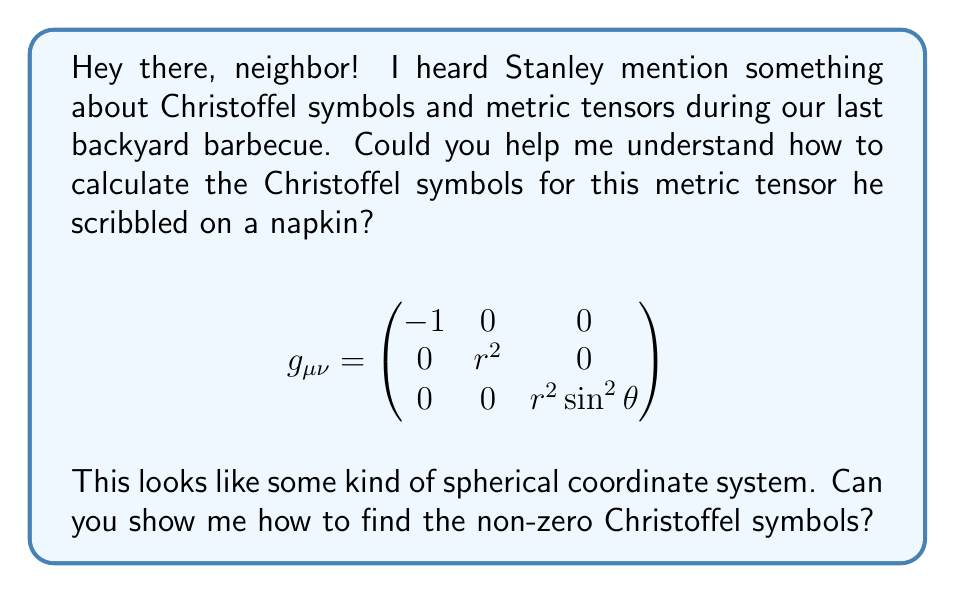What is the answer to this math problem? Sure, I'd be happy to help you understand this! Let's calculate the Christoffel symbols step-by-step:

1) The Christoffel symbols are given by the formula:

   $$\Gamma^\lambda_{\mu\nu} = \frac{1}{2}g^{\lambda\sigma}(\partial_\mu g_{\nu\sigma} + \partial_\nu g_{\mu\sigma} - \partial_\sigma g_{\mu\nu})$$

2) First, we need to find the inverse metric $g^{\mu\nu}$:

   $$g^{\mu\nu} = \begin{pmatrix}
   -1 & 0 & 0 \\
   0 & \frac{1}{r^2} & 0 \\
   0 & 0 & \frac{1}{r^2 \sin^2\theta}
   \end{pmatrix}$$

3) Now, let's calculate the partial derivatives of the metric components:

   $\partial_r g_{22} = 2r$
   $\partial_r g_{33} = 2r \sin^2\theta$
   $\partial_\theta g_{33} = 2r^2 \sin\theta \cos\theta$

4) Using these, we can calculate the non-zero Christoffel symbols:

   $\Gamma^r_{\theta\theta} = \frac{1}{2}g^{rr}(-\partial_r g_{\theta\theta}) = -r$

   $\Gamma^r_{\phi\phi} = \frac{1}{2}g^{rr}(-\partial_r g_{\phi\phi}) = -r \sin^2\theta$

   $\Gamma^\theta_{r\theta} = \Gamma^\theta_{\theta r} = \frac{1}{2}g^{\theta\theta}(\partial_r g_{\theta\theta}) = \frac{1}{r}$

   $\Gamma^\theta_{\phi\phi} = \frac{1}{2}g^{\theta\theta}(-\partial_\theta g_{\phi\phi}) = -\sin\theta \cos\theta$

   $\Gamma^\phi_{r\phi} = \Gamma^\phi_{\phi r} = \frac{1}{2}g^{\phi\phi}(\partial_r g_{\phi\phi}) = \frac{1}{r}$

   $\Gamma^\phi_{\theta\phi} = \Gamma^\phi_{\phi\theta} = \frac{1}{2}g^{\phi\phi}(\partial_\theta g_{\phi\phi}) = \cot\theta$

5) All other Christoffel symbols are zero.
Answer: Non-zero Christoffel symbols:
$\Gamma^r_{\theta\theta} = -r$
$\Gamma^r_{\phi\phi} = -r \sin^2\theta$
$\Gamma^\theta_{r\theta} = \Gamma^\theta_{\theta r} = \frac{1}{r}$
$\Gamma^\theta_{\phi\phi} = -\sin\theta \cos\theta$
$\Gamma^\phi_{r\phi} = \Gamma^\phi_{\phi r} = \frac{1}{r}$
$\Gamma^\phi_{\theta\phi} = \Gamma^\phi_{\phi\theta} = \cot\theta$ 